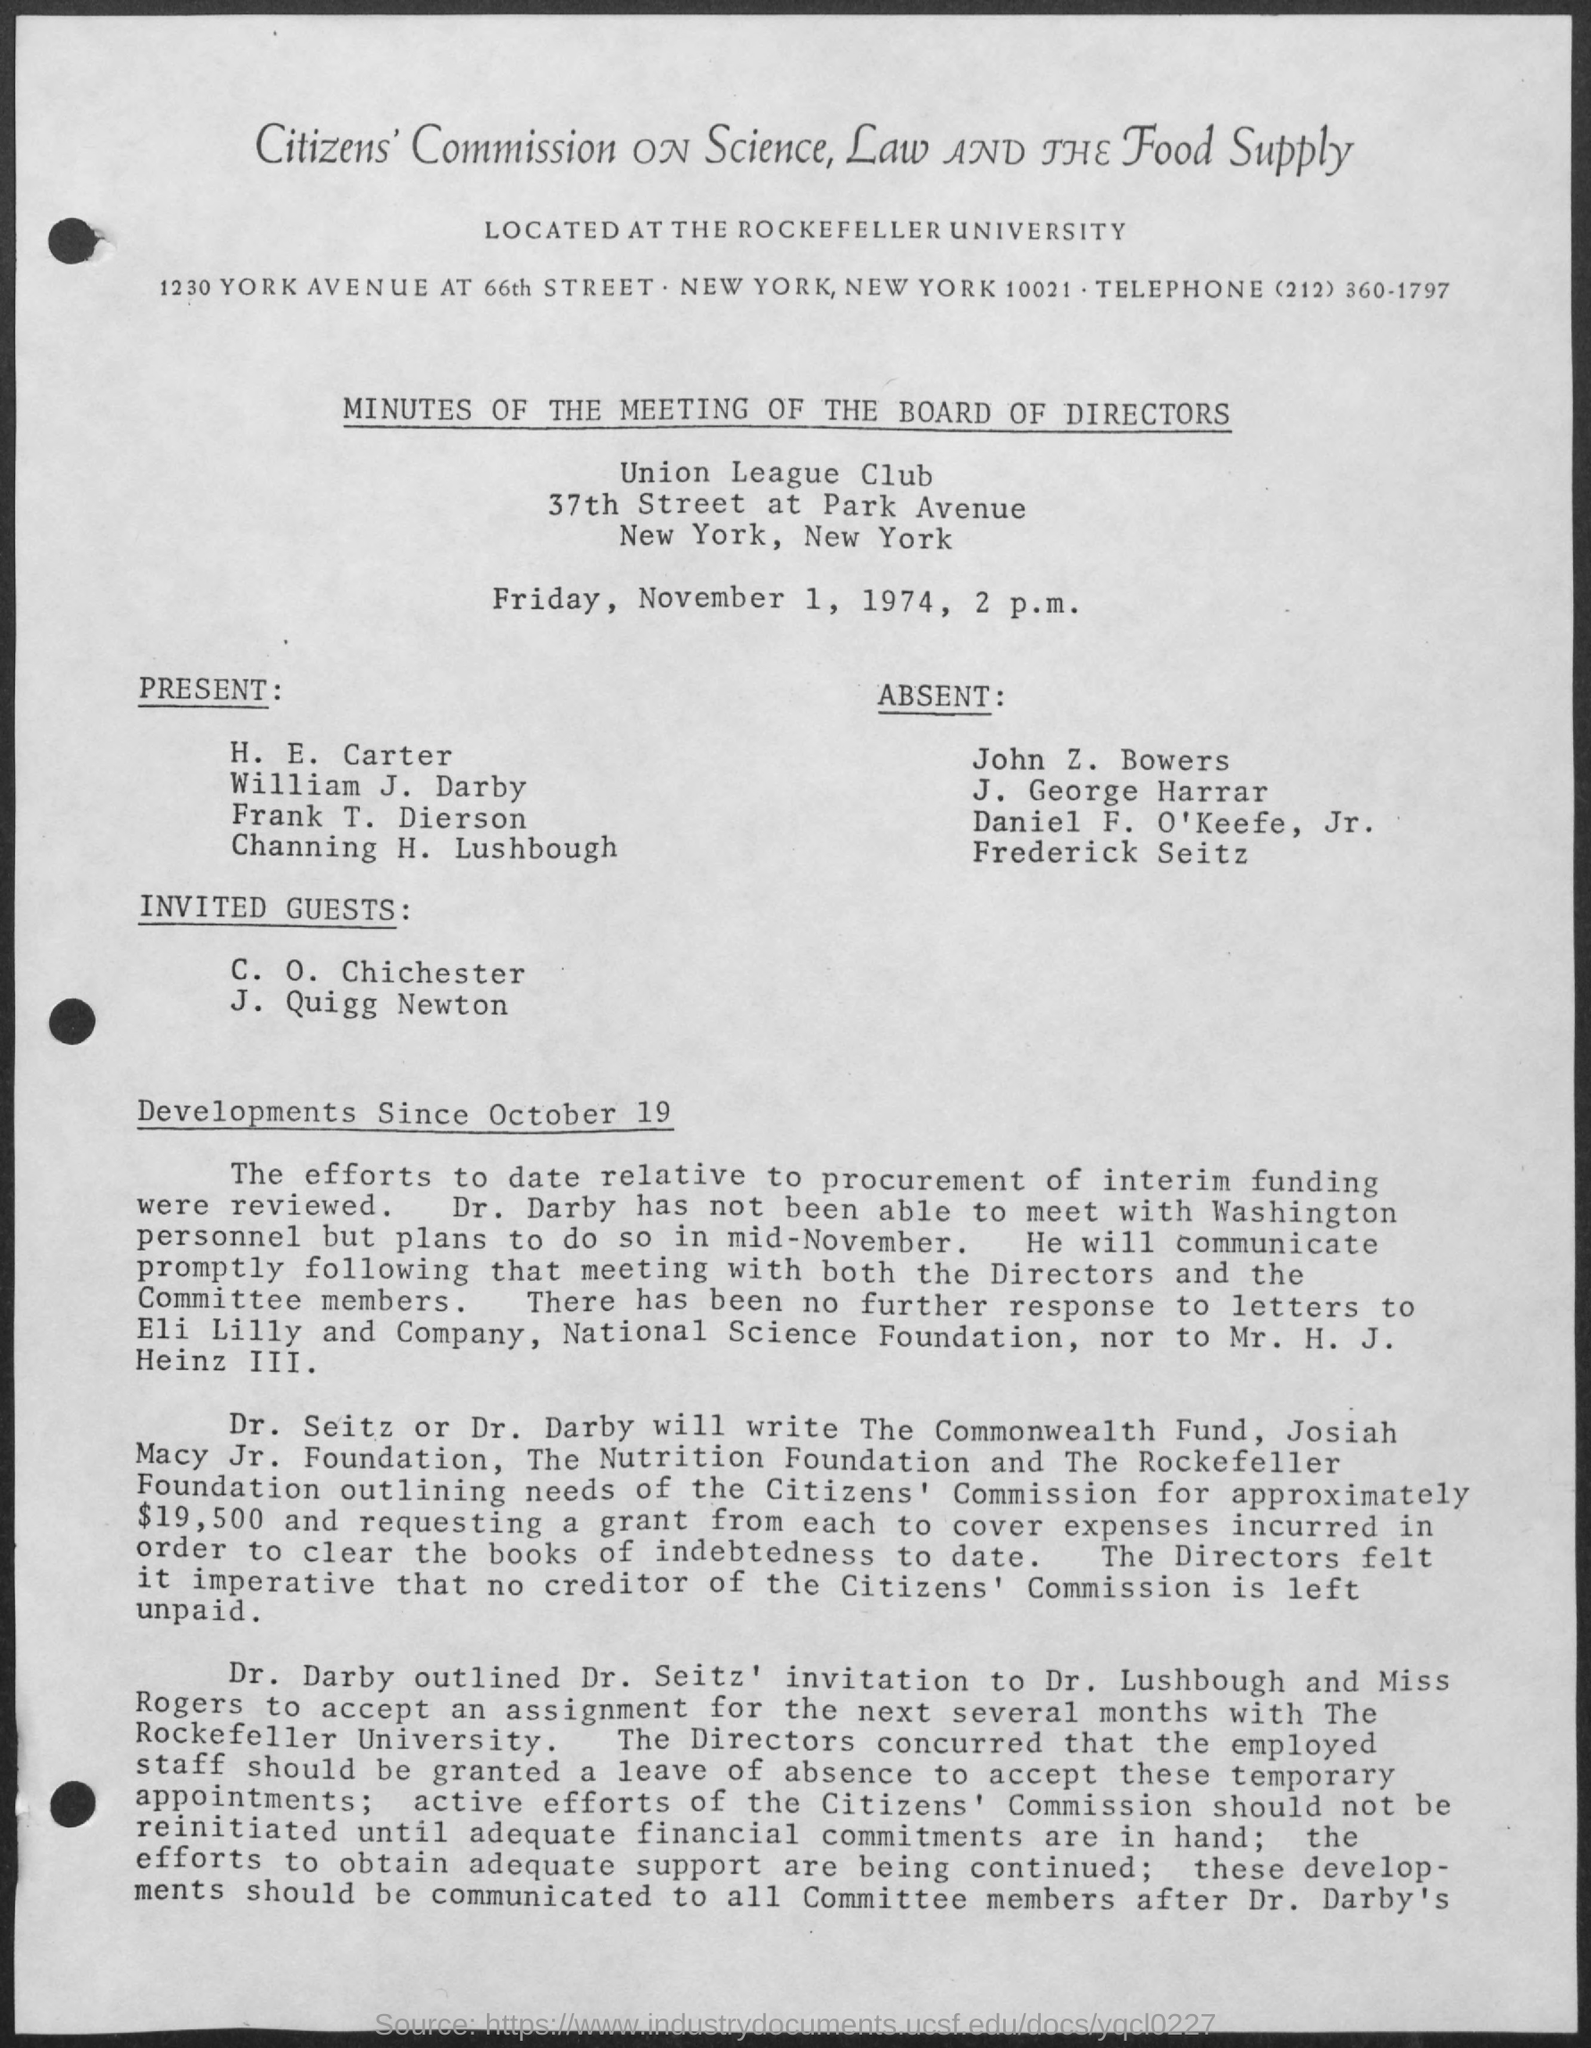What is the name of the club mentioned in the given page ?
Offer a terse response. Union League Club. What is the date mentioned in the given page ?
Your response must be concise. Friday, November 1, 1974. At what time the meeting was conducted ?
Ensure brevity in your answer.  2 p.m. 